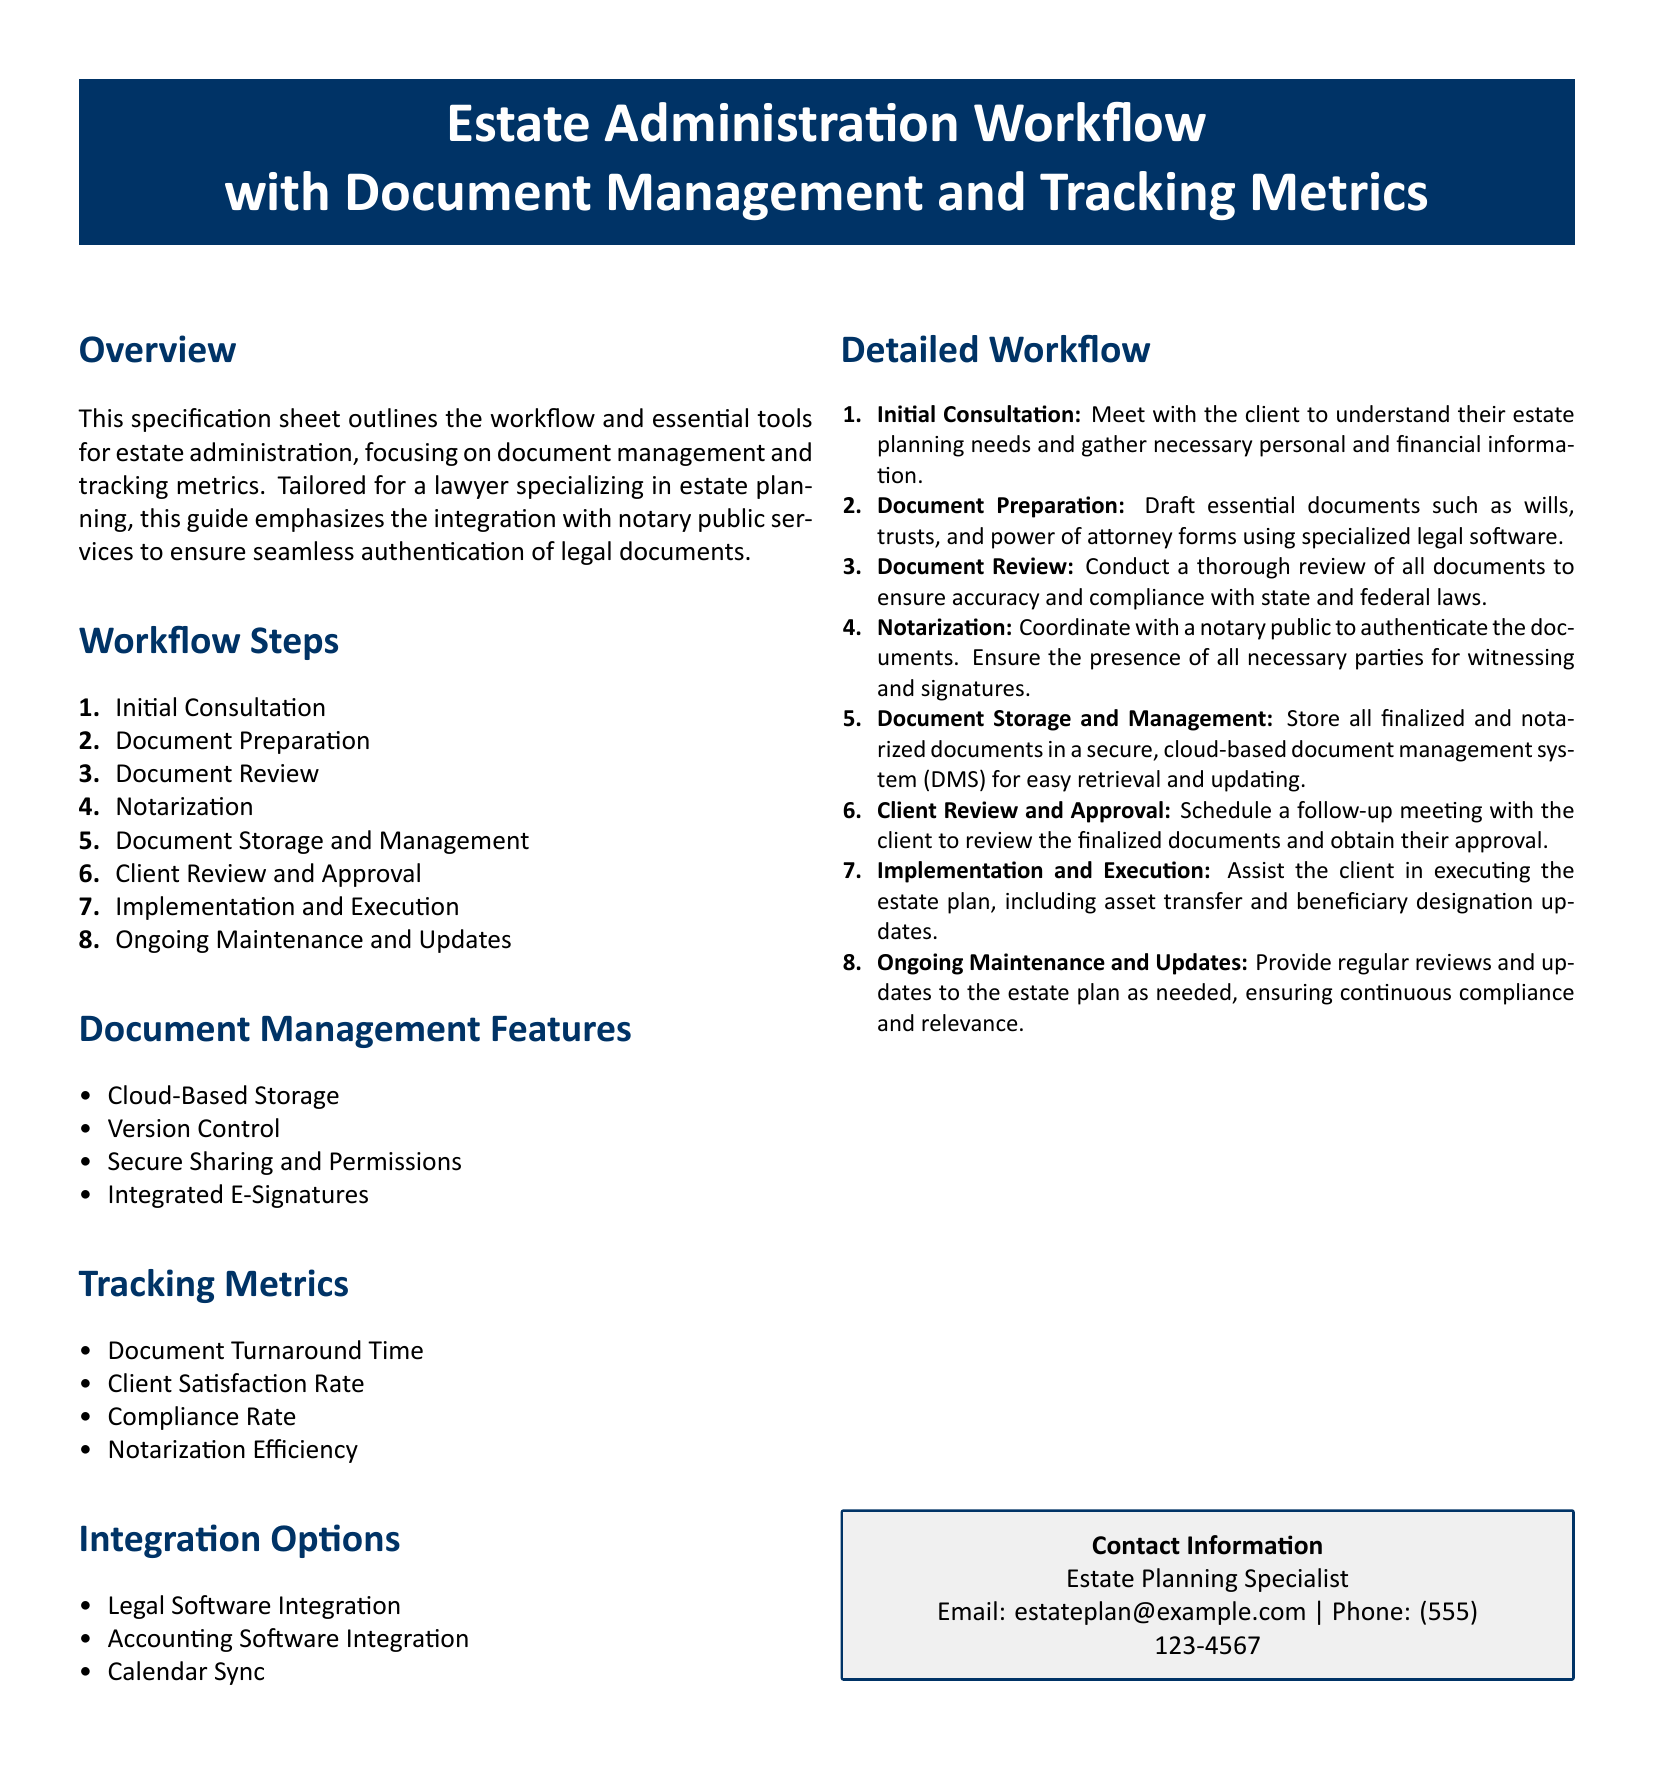What is the title of the document? The title of the document is prominently displayed at the top, identifying it as a specification sheet for estate administration.
Answer: Estate Administration Workflow with Document Management and Tracking Metrics How many workflow steps are listed? The document outlines the workflow steps in a numbered list, which can be counted.
Answer: Eight What feature is included for document management? The document lists various document management features, highlighting key functionalities.
Answer: Cloud-Based Storage What is the compliance rate metric used for? The compliance rate is one of the tracking metrics specified in the document, indicating its purpose related to legal processes.
Answer: Legal processes What does the initial consultation involve? The detailed workflow specifies the nature of the initial consultation to set expectations for clients.
Answer: Understanding needs What is the email address provided for contact? The document contains contact information, including an email for inquiries.
Answer: estateplan@example.com Which integration option is listed as part of the document management? The section on integration options specifies different interoperable systems that can enhance overall functionality.
Answer: Legal Software Integration How does the document ensure client satisfaction? The document mentions a client satisfaction rate as a tracking metric, which indicates its relevance to client interactions.
Answer: Client interactions What document is prepared after the initial consultation? The document specifies that certain essential legal documents are drafted after gathering information.
Answer: Wills, trusts, and power of attorney forms 